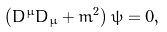<formula> <loc_0><loc_0><loc_500><loc_500>\left ( D ^ { \mu } D _ { \mu } + m ^ { 2 } \right ) \psi = 0 ,</formula> 